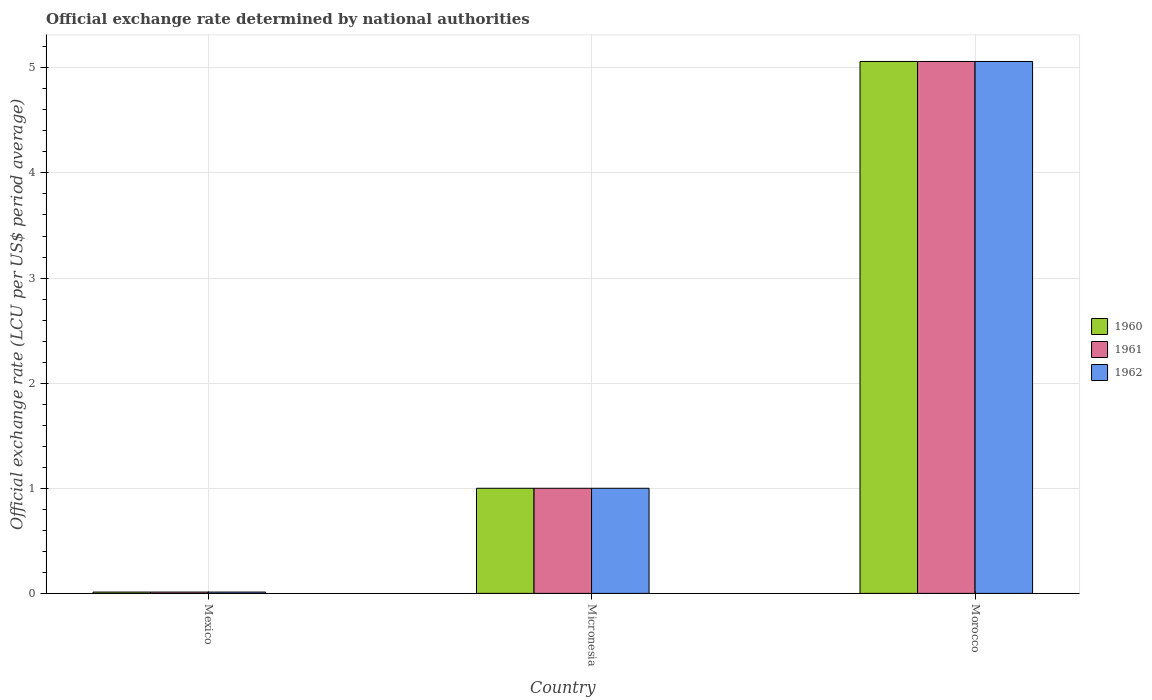Are the number of bars per tick equal to the number of legend labels?
Offer a terse response. Yes. Are the number of bars on each tick of the X-axis equal?
Offer a very short reply. Yes. How many bars are there on the 1st tick from the right?
Offer a terse response. 3. What is the label of the 3rd group of bars from the left?
Your answer should be very brief. Morocco. What is the official exchange rate in 1960 in Morocco?
Make the answer very short. 5.06. Across all countries, what is the maximum official exchange rate in 1961?
Ensure brevity in your answer.  5.06. Across all countries, what is the minimum official exchange rate in 1960?
Offer a terse response. 0.01. In which country was the official exchange rate in 1960 maximum?
Ensure brevity in your answer.  Morocco. What is the total official exchange rate in 1960 in the graph?
Provide a short and direct response. 6.07. What is the difference between the official exchange rate in 1962 in Mexico and that in Micronesia?
Provide a succinct answer. -0.99. What is the difference between the official exchange rate in 1961 in Morocco and the official exchange rate in 1962 in Mexico?
Give a very brief answer. 5.05. What is the average official exchange rate in 1962 per country?
Provide a short and direct response. 2.02. In how many countries, is the official exchange rate in 1960 greater than 1.4 LCU?
Your answer should be compact. 1. What is the ratio of the official exchange rate in 1961 in Mexico to that in Morocco?
Keep it short and to the point. 0. Is the official exchange rate in 1962 in Micronesia less than that in Morocco?
Ensure brevity in your answer.  Yes. Is the difference between the official exchange rate in 1960 in Micronesia and Morocco greater than the difference between the official exchange rate in 1961 in Micronesia and Morocco?
Offer a terse response. No. What is the difference between the highest and the second highest official exchange rate in 1962?
Give a very brief answer. 0.99. What is the difference between the highest and the lowest official exchange rate in 1960?
Your response must be concise. 5.05. In how many countries, is the official exchange rate in 1961 greater than the average official exchange rate in 1961 taken over all countries?
Offer a very short reply. 1. What does the 1st bar from the right in Mexico represents?
Provide a short and direct response. 1962. Is it the case that in every country, the sum of the official exchange rate in 1961 and official exchange rate in 1962 is greater than the official exchange rate in 1960?
Provide a succinct answer. Yes. What is the difference between two consecutive major ticks on the Y-axis?
Your response must be concise. 1. Does the graph contain grids?
Your answer should be compact. Yes. Where does the legend appear in the graph?
Provide a short and direct response. Center right. How many legend labels are there?
Provide a succinct answer. 3. What is the title of the graph?
Keep it short and to the point. Official exchange rate determined by national authorities. Does "1961" appear as one of the legend labels in the graph?
Your answer should be very brief. Yes. What is the label or title of the X-axis?
Your answer should be compact. Country. What is the label or title of the Y-axis?
Give a very brief answer. Official exchange rate (LCU per US$ period average). What is the Official exchange rate (LCU per US$ period average) in 1960 in Mexico?
Your answer should be very brief. 0.01. What is the Official exchange rate (LCU per US$ period average) of 1961 in Mexico?
Make the answer very short. 0.01. What is the Official exchange rate (LCU per US$ period average) of 1962 in Mexico?
Provide a short and direct response. 0.01. What is the Official exchange rate (LCU per US$ period average) in 1962 in Micronesia?
Your response must be concise. 1. What is the Official exchange rate (LCU per US$ period average) of 1960 in Morocco?
Your response must be concise. 5.06. What is the Official exchange rate (LCU per US$ period average) in 1961 in Morocco?
Keep it short and to the point. 5.06. What is the Official exchange rate (LCU per US$ period average) of 1962 in Morocco?
Give a very brief answer. 5.06. Across all countries, what is the maximum Official exchange rate (LCU per US$ period average) of 1960?
Give a very brief answer. 5.06. Across all countries, what is the maximum Official exchange rate (LCU per US$ period average) in 1961?
Your response must be concise. 5.06. Across all countries, what is the maximum Official exchange rate (LCU per US$ period average) in 1962?
Give a very brief answer. 5.06. Across all countries, what is the minimum Official exchange rate (LCU per US$ period average) of 1960?
Provide a succinct answer. 0.01. Across all countries, what is the minimum Official exchange rate (LCU per US$ period average) of 1961?
Your answer should be very brief. 0.01. Across all countries, what is the minimum Official exchange rate (LCU per US$ period average) of 1962?
Your response must be concise. 0.01. What is the total Official exchange rate (LCU per US$ period average) of 1960 in the graph?
Your response must be concise. 6.07. What is the total Official exchange rate (LCU per US$ period average) of 1961 in the graph?
Make the answer very short. 6.07. What is the total Official exchange rate (LCU per US$ period average) of 1962 in the graph?
Your response must be concise. 6.07. What is the difference between the Official exchange rate (LCU per US$ period average) in 1960 in Mexico and that in Micronesia?
Your response must be concise. -0.99. What is the difference between the Official exchange rate (LCU per US$ period average) of 1961 in Mexico and that in Micronesia?
Your answer should be compact. -0.99. What is the difference between the Official exchange rate (LCU per US$ period average) in 1962 in Mexico and that in Micronesia?
Ensure brevity in your answer.  -0.99. What is the difference between the Official exchange rate (LCU per US$ period average) of 1960 in Mexico and that in Morocco?
Keep it short and to the point. -5.05. What is the difference between the Official exchange rate (LCU per US$ period average) in 1961 in Mexico and that in Morocco?
Provide a short and direct response. -5.05. What is the difference between the Official exchange rate (LCU per US$ period average) in 1962 in Mexico and that in Morocco?
Your response must be concise. -5.05. What is the difference between the Official exchange rate (LCU per US$ period average) in 1960 in Micronesia and that in Morocco?
Give a very brief answer. -4.06. What is the difference between the Official exchange rate (LCU per US$ period average) of 1961 in Micronesia and that in Morocco?
Keep it short and to the point. -4.06. What is the difference between the Official exchange rate (LCU per US$ period average) of 1962 in Micronesia and that in Morocco?
Provide a short and direct response. -4.06. What is the difference between the Official exchange rate (LCU per US$ period average) in 1960 in Mexico and the Official exchange rate (LCU per US$ period average) in 1961 in Micronesia?
Offer a very short reply. -0.99. What is the difference between the Official exchange rate (LCU per US$ period average) of 1960 in Mexico and the Official exchange rate (LCU per US$ period average) of 1962 in Micronesia?
Provide a short and direct response. -0.99. What is the difference between the Official exchange rate (LCU per US$ period average) of 1961 in Mexico and the Official exchange rate (LCU per US$ period average) of 1962 in Micronesia?
Make the answer very short. -0.99. What is the difference between the Official exchange rate (LCU per US$ period average) of 1960 in Mexico and the Official exchange rate (LCU per US$ period average) of 1961 in Morocco?
Ensure brevity in your answer.  -5.05. What is the difference between the Official exchange rate (LCU per US$ period average) in 1960 in Mexico and the Official exchange rate (LCU per US$ period average) in 1962 in Morocco?
Your response must be concise. -5.05. What is the difference between the Official exchange rate (LCU per US$ period average) in 1961 in Mexico and the Official exchange rate (LCU per US$ period average) in 1962 in Morocco?
Your response must be concise. -5.05. What is the difference between the Official exchange rate (LCU per US$ period average) of 1960 in Micronesia and the Official exchange rate (LCU per US$ period average) of 1961 in Morocco?
Ensure brevity in your answer.  -4.06. What is the difference between the Official exchange rate (LCU per US$ period average) in 1960 in Micronesia and the Official exchange rate (LCU per US$ period average) in 1962 in Morocco?
Provide a succinct answer. -4.06. What is the difference between the Official exchange rate (LCU per US$ period average) of 1961 in Micronesia and the Official exchange rate (LCU per US$ period average) of 1962 in Morocco?
Provide a succinct answer. -4.06. What is the average Official exchange rate (LCU per US$ period average) of 1960 per country?
Keep it short and to the point. 2.02. What is the average Official exchange rate (LCU per US$ period average) in 1961 per country?
Your answer should be compact. 2.02. What is the average Official exchange rate (LCU per US$ period average) in 1962 per country?
Offer a terse response. 2.02. What is the difference between the Official exchange rate (LCU per US$ period average) in 1960 and Official exchange rate (LCU per US$ period average) in 1962 in Mexico?
Make the answer very short. 0. What is the difference between the Official exchange rate (LCU per US$ period average) in 1960 and Official exchange rate (LCU per US$ period average) in 1962 in Micronesia?
Make the answer very short. 0. What is the difference between the Official exchange rate (LCU per US$ period average) in 1960 and Official exchange rate (LCU per US$ period average) in 1961 in Morocco?
Keep it short and to the point. 0. What is the difference between the Official exchange rate (LCU per US$ period average) of 1961 and Official exchange rate (LCU per US$ period average) of 1962 in Morocco?
Your response must be concise. 0. What is the ratio of the Official exchange rate (LCU per US$ period average) of 1960 in Mexico to that in Micronesia?
Your response must be concise. 0.01. What is the ratio of the Official exchange rate (LCU per US$ period average) of 1961 in Mexico to that in Micronesia?
Provide a short and direct response. 0.01. What is the ratio of the Official exchange rate (LCU per US$ period average) of 1962 in Mexico to that in Micronesia?
Ensure brevity in your answer.  0.01. What is the ratio of the Official exchange rate (LCU per US$ period average) in 1960 in Mexico to that in Morocco?
Offer a terse response. 0. What is the ratio of the Official exchange rate (LCU per US$ period average) in 1961 in Mexico to that in Morocco?
Offer a very short reply. 0. What is the ratio of the Official exchange rate (LCU per US$ period average) in 1962 in Mexico to that in Morocco?
Ensure brevity in your answer.  0. What is the ratio of the Official exchange rate (LCU per US$ period average) of 1960 in Micronesia to that in Morocco?
Offer a very short reply. 0.2. What is the ratio of the Official exchange rate (LCU per US$ period average) in 1961 in Micronesia to that in Morocco?
Provide a short and direct response. 0.2. What is the ratio of the Official exchange rate (LCU per US$ period average) in 1962 in Micronesia to that in Morocco?
Provide a succinct answer. 0.2. What is the difference between the highest and the second highest Official exchange rate (LCU per US$ period average) of 1960?
Your answer should be compact. 4.06. What is the difference between the highest and the second highest Official exchange rate (LCU per US$ period average) of 1961?
Your response must be concise. 4.06. What is the difference between the highest and the second highest Official exchange rate (LCU per US$ period average) of 1962?
Ensure brevity in your answer.  4.06. What is the difference between the highest and the lowest Official exchange rate (LCU per US$ period average) of 1960?
Provide a short and direct response. 5.05. What is the difference between the highest and the lowest Official exchange rate (LCU per US$ period average) in 1961?
Keep it short and to the point. 5.05. What is the difference between the highest and the lowest Official exchange rate (LCU per US$ period average) in 1962?
Keep it short and to the point. 5.05. 